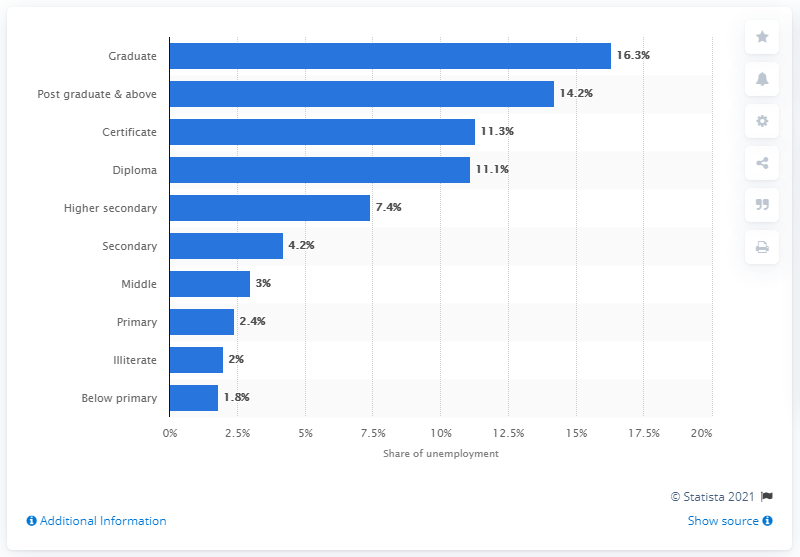What percentage of graduates made up the highest unemployment rate in 2019? In 2019, the highest unemployment rate amongst educational levels was observed in graduates, accounting for 16.3% of the total unemployment. 